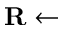Convert formula to latex. <formula><loc_0><loc_0><loc_500><loc_500>\mathbf R \gets</formula> 